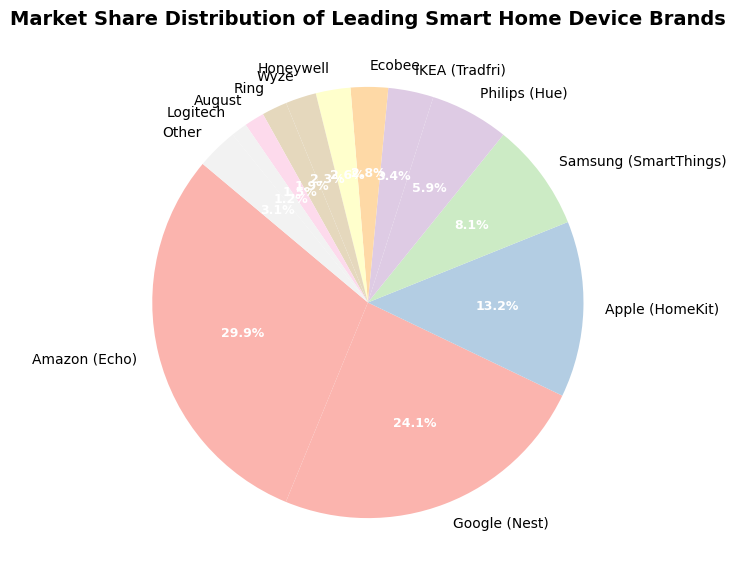Which brand has the largest market share? From the figure, Amazon (Echo) has the largest section in the pie chart, indicating it has the largest market share.
Answer: Amazon (Echo) Which brand has the second largest market share? The second largest section in the pie chart is Google (Nest), indicating it has the second largest market share.
Answer: Google (Nest) How much larger is Amazon’s market share than Apple’s? Amazon's market share is 29.9%, and Apple's (HomeKit) is 13.2%. The difference is 29.9% - 13.2% = 16.7%.
Answer: 16.7% Which brands have a market share smaller than 5%? Observing the figure, the brands with a section smaller than 5% are IKEA (Tradfri), Ecobee, Honeywell, Wyze, Ring, August, Logitech, and Other.
Answer: IKEA, Ecobee, Honeywell, Wyze, Ring, August, Logitech, Other What is the total market share of brands with less than 5% each? Summing the market shares of IKEA (3.4%), Ecobee (2.8%), Honeywell (2.6%), Wyze (2.3%), Ring (1.9%), August (1.5%), Logitech (1.2%), and Other (3.1%): 3.4 + 2.8 + 2.6 + 2.3 + 1.9 + 1.5 + 1.2 + 3.1 = 18.8%.
Answer: 18.8% Are there more brands with a market share greater than or equal to 10% or brands with a market share less than 5%? The brands with a market share greater than or equal to 10% are Amazon (29.9%), Google (24.1%), and Apple (13.2%), which are 3 in total. The brands with less than 5% are IKEA, Ecobee, Honeywell, Wyze, Ring, August, Logitech, and Other, which are 8 in total. Therefore, there are more brands with less than 5%.
Answer: Less than 5% What is the difference in market share between the third and fourth largest brands? The third largest brand is Apple (HomeKit) with 13.2% and the fourth largest brand is Samsung (SmartThings) with 8.1%. The difference is 13.2% - 8.1% = 5.1%.
Answer: 5.1% How much of the market do the top three brands account for together? Adding the market shares of Amazon (29.9%), Google (24.1%), and Apple (13.2%): 29.9 + 24.1 + 13.2 = 67.2%.
Answer: 67.2% Which brand has the smallest market share and what is it? The brand with the smallest section in the pie chart is Logitech with 1.2%.
Answer: Logitech, 1.2% What is the combined market share of brands Samsung and Philips? Adding the market shares of Samsung (8.1%) and Philips (Hue) (5.9%): 8.1 + 5.9 = 14.0%.
Answer: 14.0% 